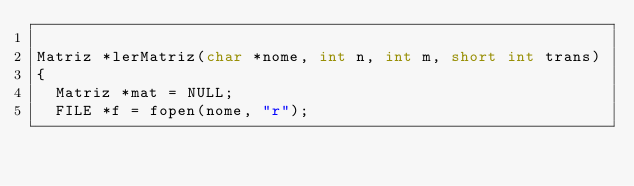Convert code to text. <code><loc_0><loc_0><loc_500><loc_500><_Cuda_>
Matriz *lerMatriz(char *nome, int n, int m, short int trans)
{
	Matriz *mat = NULL;
	FILE *f = fopen(nome, "r");</code> 